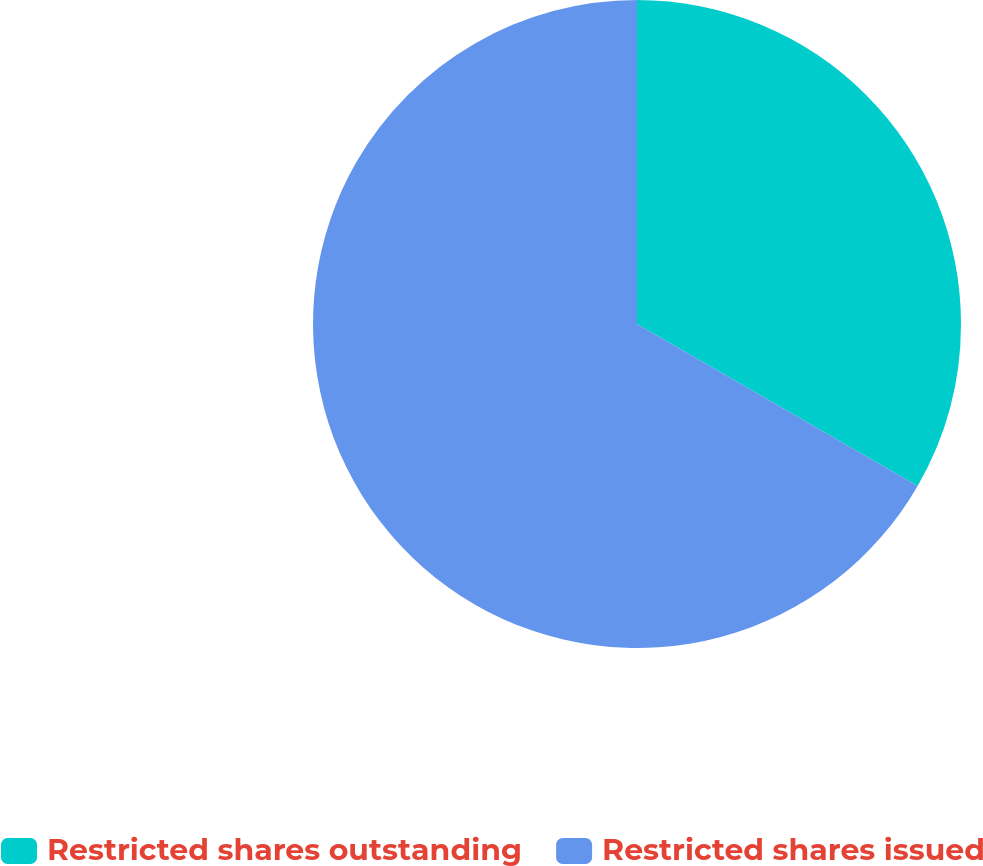Convert chart. <chart><loc_0><loc_0><loc_500><loc_500><pie_chart><fcel>Restricted shares outstanding<fcel>Restricted shares issued<nl><fcel>33.33%<fcel>66.67%<nl></chart> 